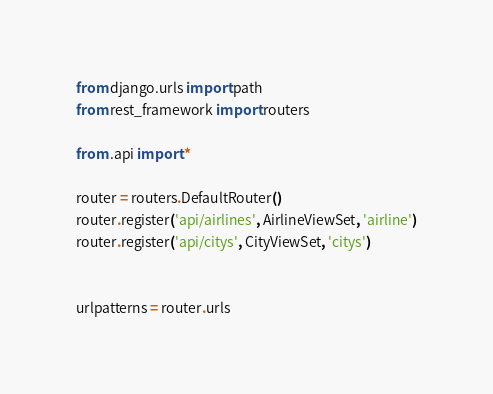Convert code to text. <code><loc_0><loc_0><loc_500><loc_500><_Python_>from django.urls import path
from rest_framework import routers

from .api import *

router = routers.DefaultRouter()
router.register('api/airlines', AirlineViewSet, 'airline')
router.register('api/citys', CityViewSet, 'citys')


urlpatterns = router.urls
</code> 